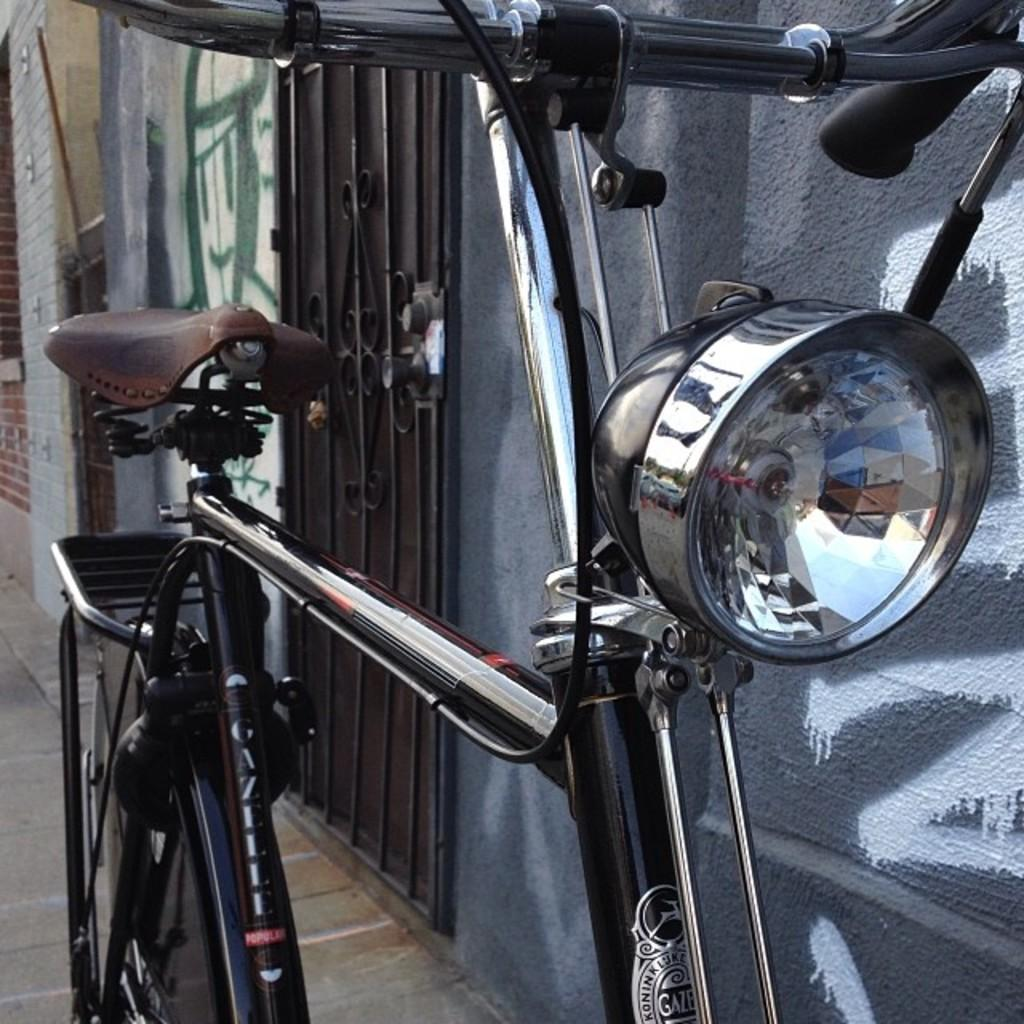What type of structures can be seen in the image? There are buildings in the image. Can you identify any specific features of the buildings? There is a door visible in the image. What mode of transportation can be seen in the image? There is a bicycle in the image. What type of game is being played in the image? There is no game being played in the image; it features buildings, a door, and a bicycle. Can you describe the sidewalk in the image? There is no sidewalk present in the image. 